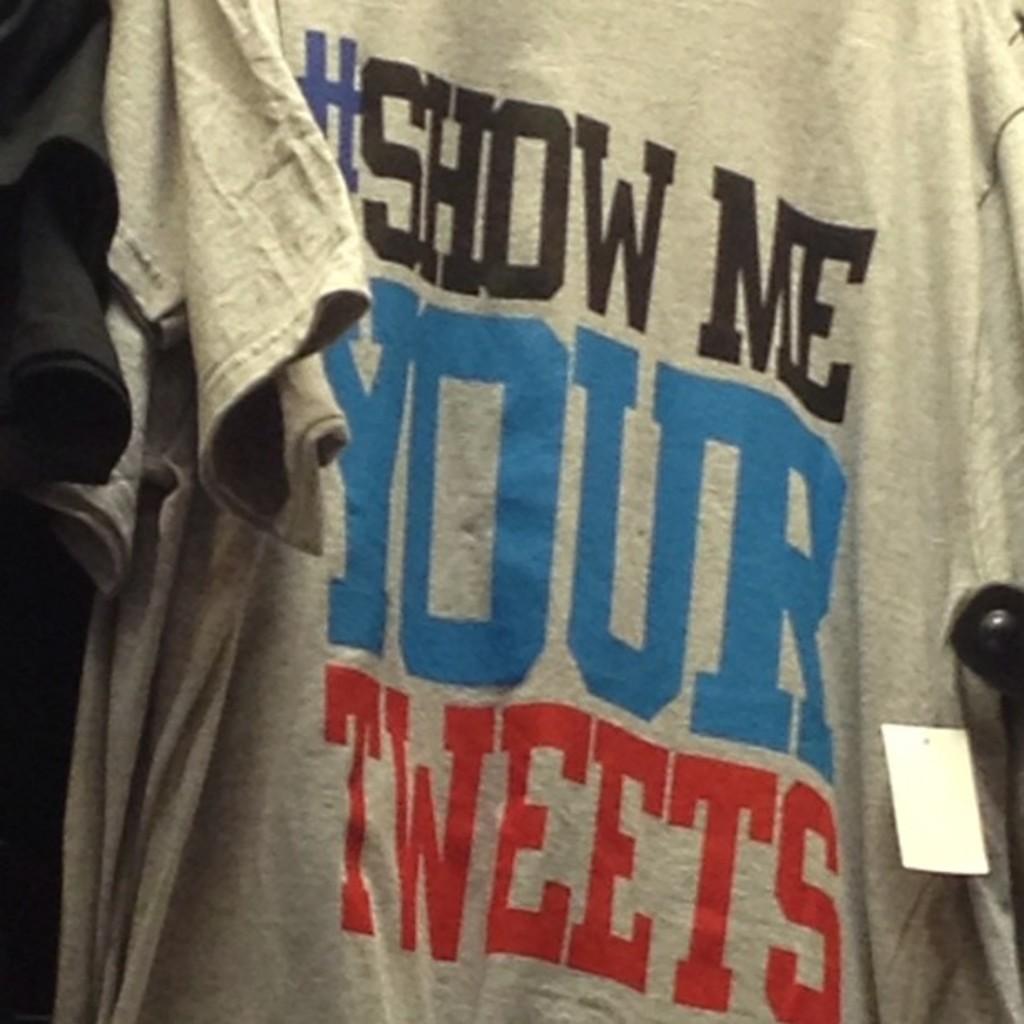What is the word in red?
Make the answer very short. Tweets. 